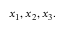Convert formula to latex. <formula><loc_0><loc_0><loc_500><loc_500>x _ { 1 } , x _ { 2 } , x _ { 3 } .</formula> 